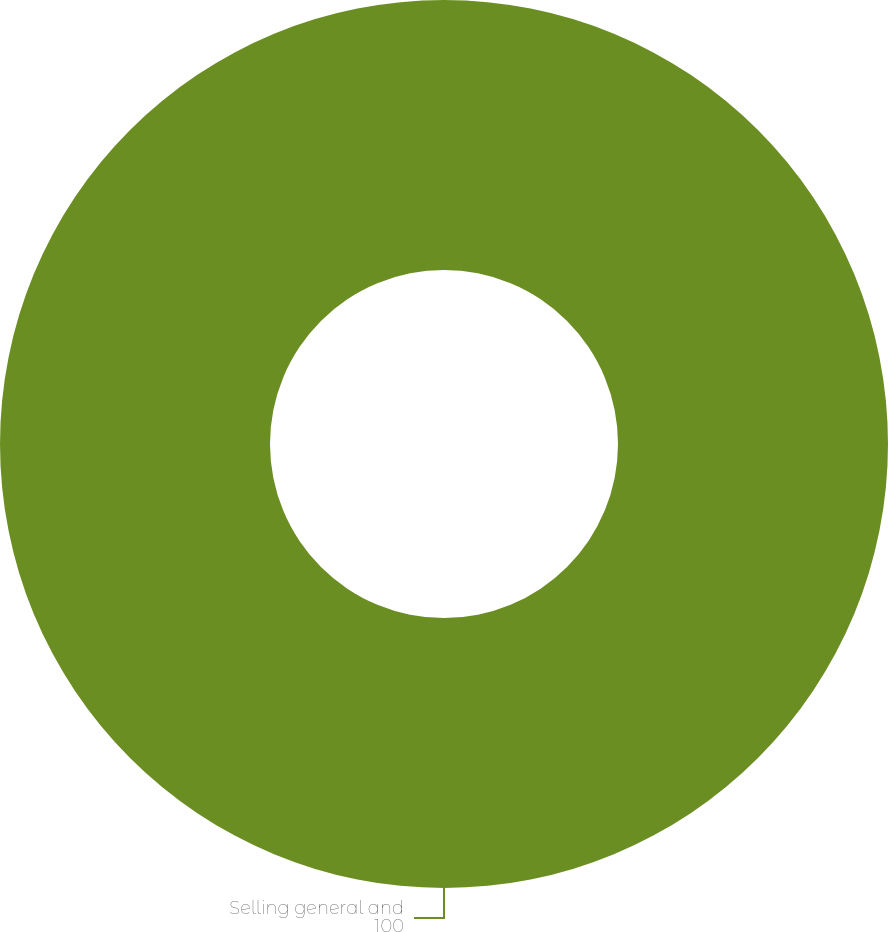Convert chart to OTSL. <chart><loc_0><loc_0><loc_500><loc_500><pie_chart><fcel>Selling general and<nl><fcel>100.0%<nl></chart> 